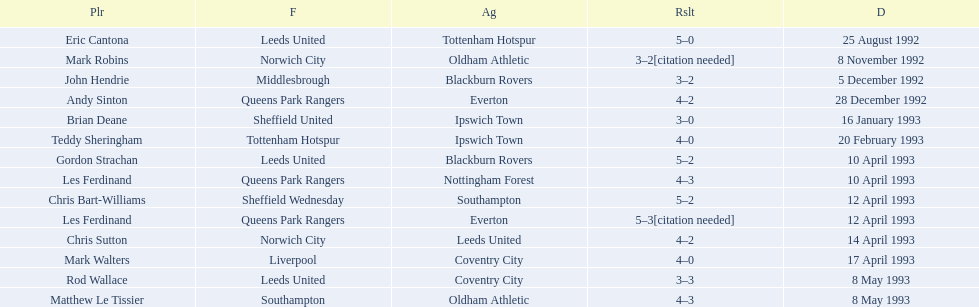Which player had the same result as mark robins? John Hendrie. 